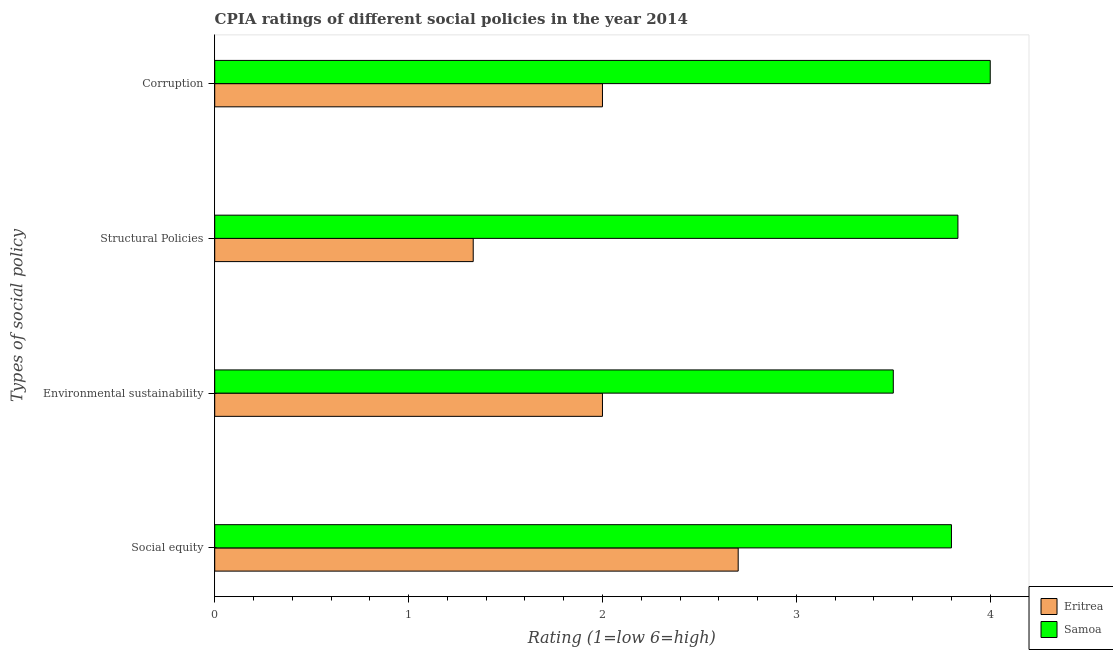How many different coloured bars are there?
Provide a short and direct response. 2. Are the number of bars per tick equal to the number of legend labels?
Give a very brief answer. Yes. Are the number of bars on each tick of the Y-axis equal?
Your answer should be very brief. Yes. What is the label of the 4th group of bars from the top?
Ensure brevity in your answer.  Social equity. What is the cpia rating of social equity in Samoa?
Offer a very short reply. 3.8. Across all countries, what is the minimum cpia rating of structural policies?
Give a very brief answer. 1.33. In which country was the cpia rating of social equity maximum?
Provide a succinct answer. Samoa. In which country was the cpia rating of social equity minimum?
Give a very brief answer. Eritrea. What is the total cpia rating of environmental sustainability in the graph?
Your response must be concise. 5.5. What is the difference between the cpia rating of corruption in Samoa and the cpia rating of environmental sustainability in Eritrea?
Your answer should be very brief. 2. What is the average cpia rating of structural policies per country?
Your answer should be very brief. 2.58. What is the difference between the cpia rating of corruption and cpia rating of social equity in Samoa?
Offer a very short reply. 0.2. In how many countries, is the cpia rating of structural policies greater than 1 ?
Give a very brief answer. 2. What is the ratio of the cpia rating of environmental sustainability in Eritrea to that in Samoa?
Provide a short and direct response. 0.57. Is the cpia rating of social equity in Samoa less than that in Eritrea?
Provide a succinct answer. No. Is the difference between the cpia rating of social equity in Samoa and Eritrea greater than the difference between the cpia rating of corruption in Samoa and Eritrea?
Make the answer very short. No. What is the difference between the highest and the second highest cpia rating of environmental sustainability?
Your response must be concise. 1.5. What is the difference between the highest and the lowest cpia rating of structural policies?
Your answer should be compact. 2.5. Is the sum of the cpia rating of environmental sustainability in Eritrea and Samoa greater than the maximum cpia rating of structural policies across all countries?
Make the answer very short. Yes. What does the 1st bar from the top in Social equity represents?
Make the answer very short. Samoa. What does the 2nd bar from the bottom in Structural Policies represents?
Offer a very short reply. Samoa. Is it the case that in every country, the sum of the cpia rating of social equity and cpia rating of environmental sustainability is greater than the cpia rating of structural policies?
Offer a very short reply. Yes. Are all the bars in the graph horizontal?
Your response must be concise. Yes. How many countries are there in the graph?
Your answer should be very brief. 2. Are the values on the major ticks of X-axis written in scientific E-notation?
Your answer should be compact. No. Where does the legend appear in the graph?
Ensure brevity in your answer.  Bottom right. How many legend labels are there?
Provide a succinct answer. 2. What is the title of the graph?
Ensure brevity in your answer.  CPIA ratings of different social policies in the year 2014. What is the label or title of the X-axis?
Ensure brevity in your answer.  Rating (1=low 6=high). What is the label or title of the Y-axis?
Provide a short and direct response. Types of social policy. What is the Rating (1=low 6=high) of Eritrea in Social equity?
Provide a short and direct response. 2.7. What is the Rating (1=low 6=high) in Eritrea in Environmental sustainability?
Keep it short and to the point. 2. What is the Rating (1=low 6=high) in Samoa in Environmental sustainability?
Offer a terse response. 3.5. What is the Rating (1=low 6=high) of Eritrea in Structural Policies?
Keep it short and to the point. 1.33. What is the Rating (1=low 6=high) in Samoa in Structural Policies?
Provide a succinct answer. 3.83. What is the Rating (1=low 6=high) of Eritrea in Corruption?
Offer a very short reply. 2. Across all Types of social policy, what is the maximum Rating (1=low 6=high) of Eritrea?
Give a very brief answer. 2.7. Across all Types of social policy, what is the minimum Rating (1=low 6=high) of Eritrea?
Offer a very short reply. 1.33. Across all Types of social policy, what is the minimum Rating (1=low 6=high) in Samoa?
Your response must be concise. 3.5. What is the total Rating (1=low 6=high) of Eritrea in the graph?
Your answer should be compact. 8.03. What is the total Rating (1=low 6=high) of Samoa in the graph?
Your answer should be compact. 15.13. What is the difference between the Rating (1=low 6=high) in Eritrea in Social equity and that in Environmental sustainability?
Your answer should be very brief. 0.7. What is the difference between the Rating (1=low 6=high) in Samoa in Social equity and that in Environmental sustainability?
Provide a succinct answer. 0.3. What is the difference between the Rating (1=low 6=high) in Eritrea in Social equity and that in Structural Policies?
Your answer should be compact. 1.37. What is the difference between the Rating (1=low 6=high) of Samoa in Social equity and that in Structural Policies?
Make the answer very short. -0.03. What is the difference between the Rating (1=low 6=high) in Samoa in Social equity and that in Corruption?
Your response must be concise. -0.2. What is the difference between the Rating (1=low 6=high) of Eritrea in Environmental sustainability and that in Corruption?
Make the answer very short. 0. What is the difference between the Rating (1=low 6=high) of Samoa in Environmental sustainability and that in Corruption?
Your response must be concise. -0.5. What is the difference between the Rating (1=low 6=high) in Eritrea in Structural Policies and that in Corruption?
Your response must be concise. -0.67. What is the difference between the Rating (1=low 6=high) of Samoa in Structural Policies and that in Corruption?
Your answer should be compact. -0.17. What is the difference between the Rating (1=low 6=high) of Eritrea in Social equity and the Rating (1=low 6=high) of Samoa in Environmental sustainability?
Keep it short and to the point. -0.8. What is the difference between the Rating (1=low 6=high) in Eritrea in Social equity and the Rating (1=low 6=high) in Samoa in Structural Policies?
Your response must be concise. -1.13. What is the difference between the Rating (1=low 6=high) of Eritrea in Environmental sustainability and the Rating (1=low 6=high) of Samoa in Structural Policies?
Provide a short and direct response. -1.83. What is the difference between the Rating (1=low 6=high) in Eritrea in Structural Policies and the Rating (1=low 6=high) in Samoa in Corruption?
Your response must be concise. -2.67. What is the average Rating (1=low 6=high) in Eritrea per Types of social policy?
Your answer should be very brief. 2.01. What is the average Rating (1=low 6=high) of Samoa per Types of social policy?
Keep it short and to the point. 3.78. What is the difference between the Rating (1=low 6=high) of Eritrea and Rating (1=low 6=high) of Samoa in Environmental sustainability?
Offer a terse response. -1.5. What is the ratio of the Rating (1=low 6=high) in Eritrea in Social equity to that in Environmental sustainability?
Ensure brevity in your answer.  1.35. What is the ratio of the Rating (1=low 6=high) in Samoa in Social equity to that in Environmental sustainability?
Ensure brevity in your answer.  1.09. What is the ratio of the Rating (1=low 6=high) of Eritrea in Social equity to that in Structural Policies?
Provide a short and direct response. 2.02. What is the ratio of the Rating (1=low 6=high) of Samoa in Social equity to that in Structural Policies?
Ensure brevity in your answer.  0.99. What is the ratio of the Rating (1=low 6=high) in Eritrea in Social equity to that in Corruption?
Provide a short and direct response. 1.35. What is the ratio of the Rating (1=low 6=high) in Samoa in Social equity to that in Corruption?
Offer a terse response. 0.95. What is the ratio of the Rating (1=low 6=high) in Eritrea in Environmental sustainability to that in Structural Policies?
Make the answer very short. 1.5. What is the ratio of the Rating (1=low 6=high) of Samoa in Structural Policies to that in Corruption?
Your answer should be compact. 0.96. What is the difference between the highest and the lowest Rating (1=low 6=high) of Eritrea?
Offer a very short reply. 1.37. What is the difference between the highest and the lowest Rating (1=low 6=high) of Samoa?
Your answer should be very brief. 0.5. 